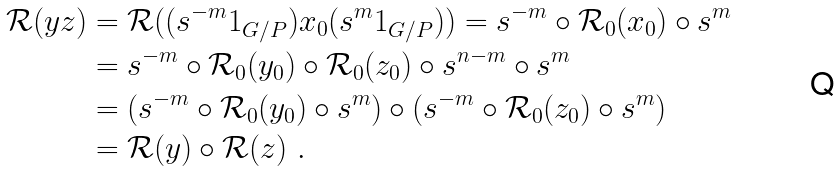Convert formula to latex. <formula><loc_0><loc_0><loc_500><loc_500>\mathcal { R } ( y z ) & = \mathcal { R } ( ( s ^ { - m } 1 _ { G / P } ) x _ { 0 } ( s ^ { m } 1 _ { G / P } ) ) = s ^ { - m } \circ \mathcal { R } _ { 0 } ( x _ { 0 } ) \circ s ^ { m } \\ & = s ^ { - m } \circ \mathcal { R } _ { 0 } ( y _ { 0 } ) \circ \mathcal { R } _ { 0 } ( z _ { 0 } ) \circ s ^ { n - m } \circ s ^ { m } \\ & = ( s ^ { - m } \circ \mathcal { R } _ { 0 } ( y _ { 0 } ) \circ s ^ { m } ) \circ ( s ^ { - m } \circ \mathcal { R } _ { 0 } ( z _ { 0 } ) \circ s ^ { m } ) \\ & = \mathcal { R } ( y ) \circ \mathcal { R } ( z ) \ .</formula> 